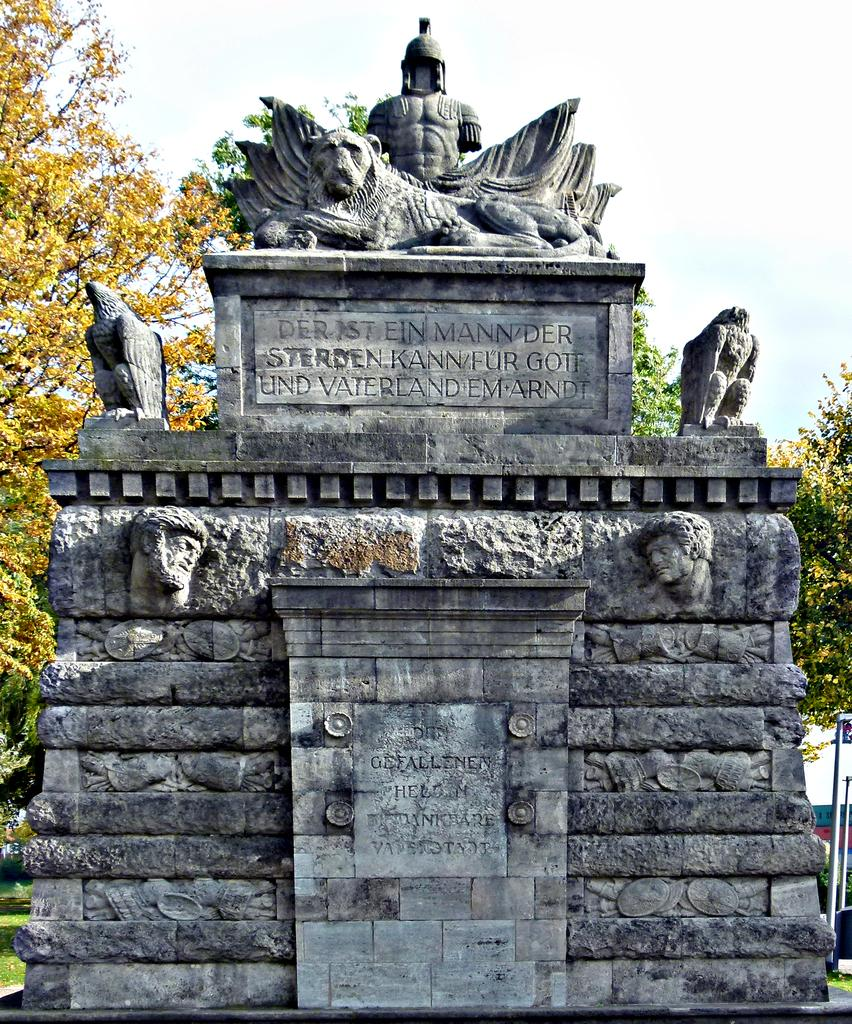What can be seen in the foreground of the image? There are sculptures and text on a stone in the foreground of the image. What type of vegetation is visible in the background of the image? There are trees in the background of the image. What else can be seen in the background of the image? The sky is visible in the background of the image. Can you tell me how many vegetables are growing near the sculptures in the image? There are no vegetables present in the image; it features sculptures and text on a stone in the foreground, with trees and the sky visible in the background. 